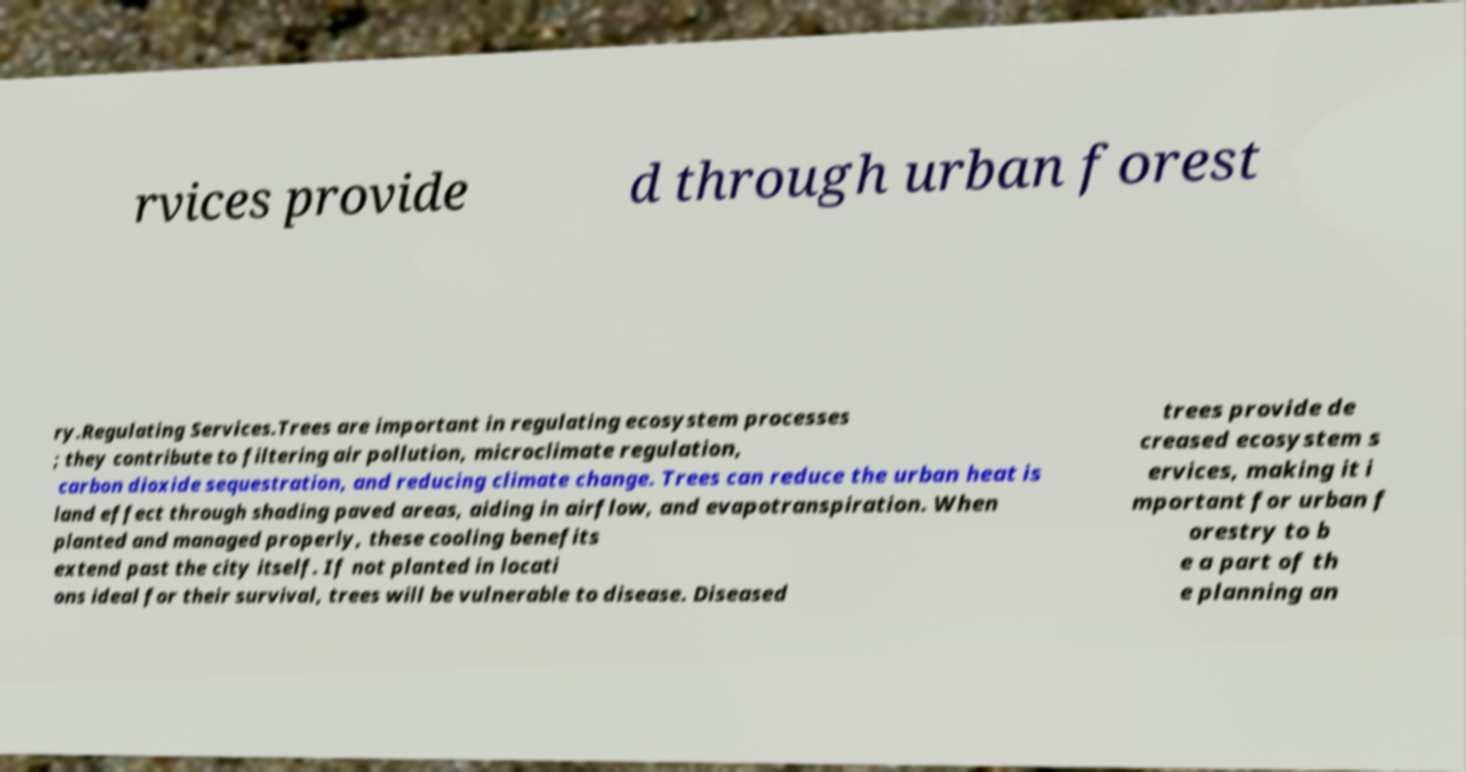Can you accurately transcribe the text from the provided image for me? rvices provide d through urban forest ry.Regulating Services.Trees are important in regulating ecosystem processes ; they contribute to filtering air pollution, microclimate regulation, carbon dioxide sequestration, and reducing climate change. Trees can reduce the urban heat is land effect through shading paved areas, aiding in airflow, and evapotranspiration. When planted and managed properly, these cooling benefits extend past the city itself. If not planted in locati ons ideal for their survival, trees will be vulnerable to disease. Diseased trees provide de creased ecosystem s ervices, making it i mportant for urban f orestry to b e a part of th e planning an 